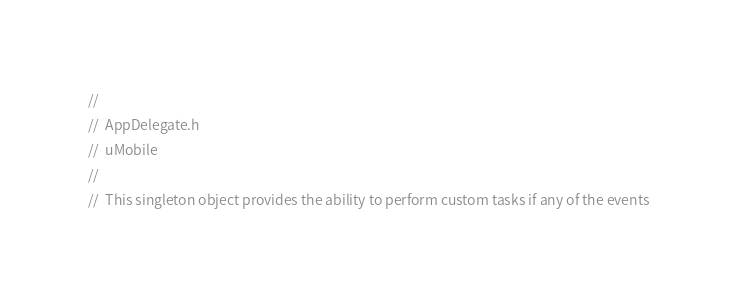Convert code to text. <code><loc_0><loc_0><loc_500><loc_500><_C_>//
//  AppDelegate.h
//  uMobile
//
//  This singleton object provides the ability to perform custom tasks if any of the events</code> 